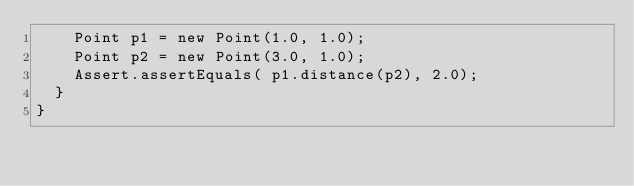<code> <loc_0><loc_0><loc_500><loc_500><_Java_>    Point p1 = new Point(1.0, 1.0);
    Point p2 = new Point(3.0, 1.0);
    Assert.assertEquals( p1.distance(p2), 2.0);
  }
}</code> 